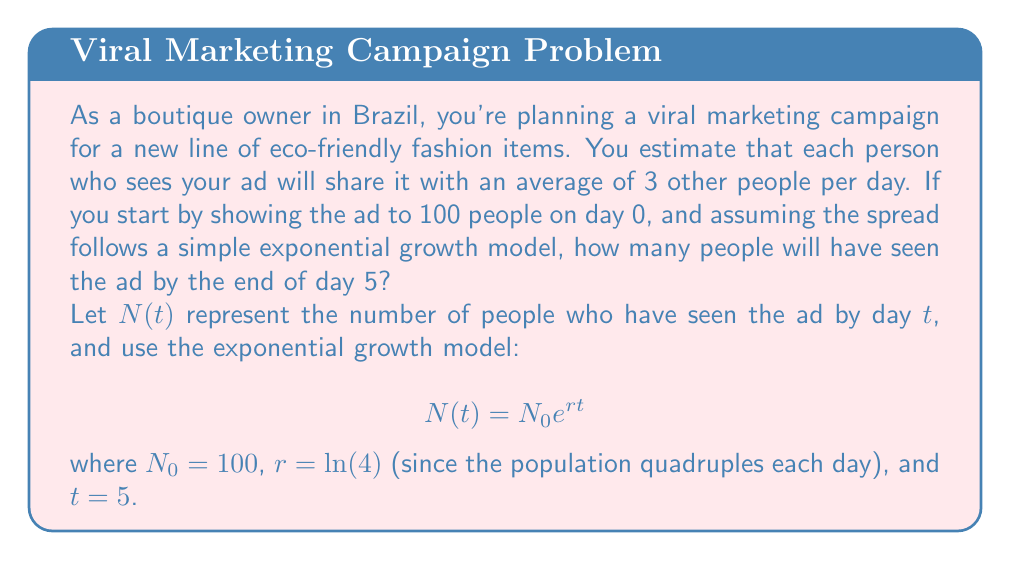Help me with this question. To solve this problem, we'll use the exponential growth model:

$$N(t) = N_0 e^{rt}$$

Where:
- $N(t)$ is the number of people who have seen the ad by day $t$
- $N_0$ is the initial number of people (100 in this case)
- $r$ is the growth rate
- $t$ is the time in days (5 in this case)

First, we need to calculate the growth rate $r$:
The population quadruples each day, so we can set up the equation:
$$4 = e^r$$
Taking the natural logarithm of both sides:
$$\ln(4) = r$$

Now we can plug all the values into our exponential growth equation:
$$N(5) = 100 \cdot e^{\ln(4) \cdot 5}$$

Simplify:
$$N(5) = 100 \cdot (e^{\ln(4)})^5$$
$$N(5) = 100 \cdot 4^5$$
$$N(5) = 100 \cdot 1024$$
$$N(5) = 102,400$$

Therefore, by the end of day 5, approximately 102,400 people will have seen the ad.
Answer: 102,400 people 